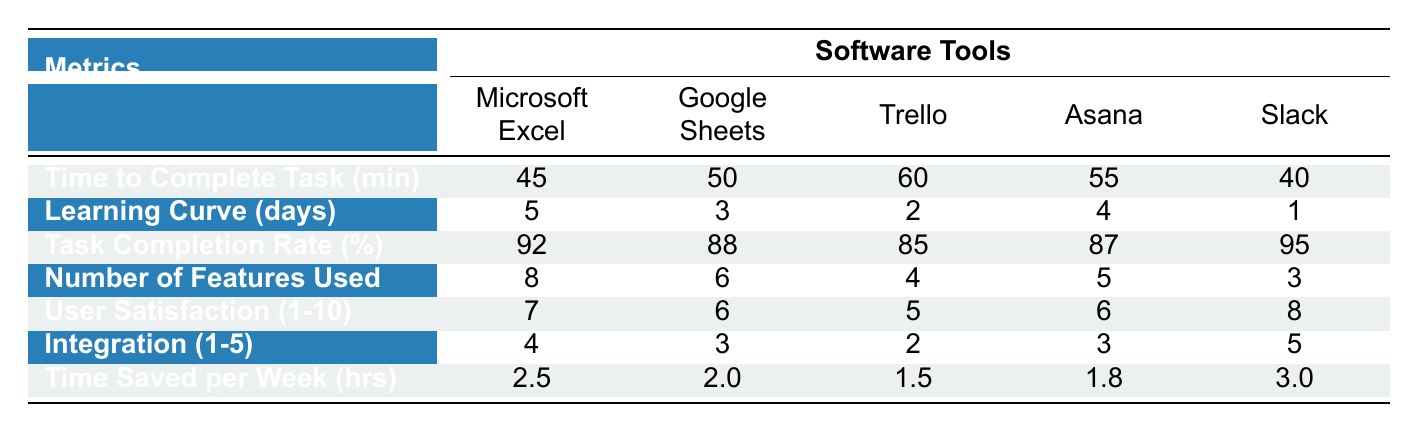What is the time to complete an assigned task using Slack? According to the table, the time listed for Slack is 40 minutes.
Answer: 40 minutes Which software tool has the shortest learning curve? The learning curve for each tool is listed, and Slack has the lowest at 1 day.
Answer: Slack What is the task completion rate for Microsoft Excel? The task completion rate for Microsoft Excel is shown as 92%.
Answer: 92% How many features are used with Trello? The number of features used with Trello is stated as 4 in the table.
Answer: 4 What is the average task completion rate for all software tools? To find the average, add the completion rates (92 + 88 + 85 + 87 + 95 = 447) and divide by the number of tools (447 / 5 = 89.4).
Answer: 89.4% Is the user satisfaction score for Asana greater than 6? The user satisfaction score for Asana is listed as 6, so it is not greater.
Answer: No Which software tool has the highest time saved per week? The time saved per week for each tool is compared, and Slack has the highest at 3.0 hours.
Answer: Slack What is the difference in time to complete tasks between Microsoft Excel and Google Sheets? The time for Microsoft Excel is 45 minutes and for Google Sheets is 50 minutes. The difference is 50 - 45 = 5 minutes.
Answer: 5 minutes Does Trello have more features used than Slack? Trello has 4 features, while Slack has 3. Since 4 is greater than 3, the answer is yes.
Answer: Yes What is the total learning curve for all the software tools combined? The learning curves are summed (5 + 3 + 2 + 4 + 1 = 15 days) for all tools to find the total.
Answer: 15 days 